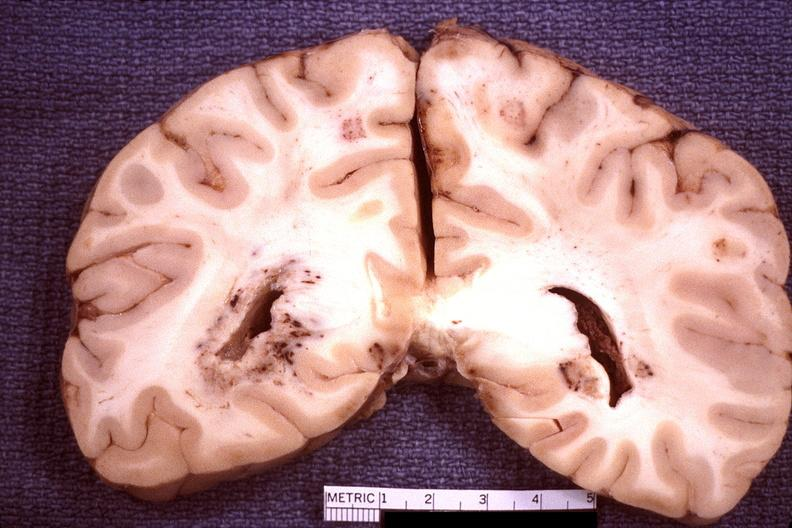what does this image show?
Answer the question using a single word or phrase. Brain 